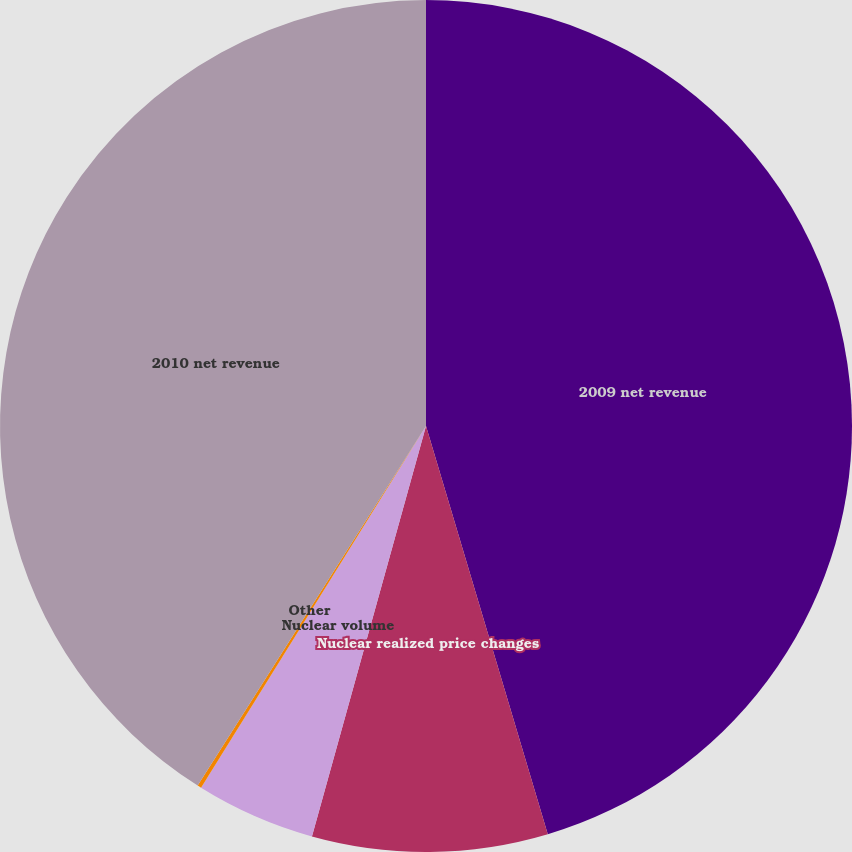Convert chart to OTSL. <chart><loc_0><loc_0><loc_500><loc_500><pie_chart><fcel>2009 net revenue<fcel>Nuclear realized price changes<fcel>Nuclear volume<fcel>Other<fcel>2010 net revenue<nl><fcel>45.39%<fcel>8.93%<fcel>4.54%<fcel>0.15%<fcel>41.0%<nl></chart> 